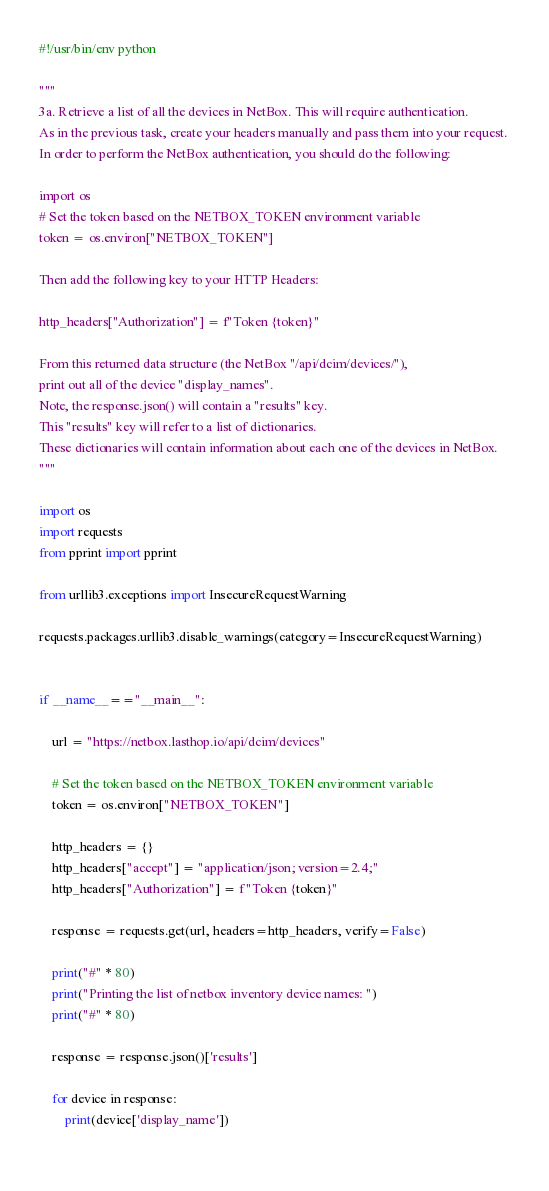<code> <loc_0><loc_0><loc_500><loc_500><_Python_>#!/usr/bin/env python

"""
3a. Retrieve a list of all the devices in NetBox. This will require authentication. 
As in the previous task, create your headers manually and pass them into your request. 
In order to perform the NetBox authentication, you should do the following:

import os
# Set the token based on the NETBOX_TOKEN environment variable
token = os.environ["NETBOX_TOKEN"]

Then add the following key to your HTTP Headers:

http_headers["Authorization"] = f"Token {token}"

From this returned data structure (the NetBox "/api/dcim/devices/"), 
print out all of the device "display_names". 
Note, the response.json() will contain a "results" key. 
This "results" key will refer to a list of dictionaries. 
These dictionaries will contain information about each one of the devices in NetBox.
"""

import os
import requests
from pprint import pprint

from urllib3.exceptions import InsecureRequestWarning

requests.packages.urllib3.disable_warnings(category=InsecureRequestWarning)


if __name__=="__main__":

    url = "https://netbox.lasthop.io/api/dcim/devices"

    # Set the token based on the NETBOX_TOKEN environment variable
    token = os.environ["NETBOX_TOKEN"]

    http_headers = {}
    http_headers["accept"] = "application/json; version=2.4;"
    http_headers["Authorization"] = f"Token {token}"

    response = requests.get(url, headers=http_headers, verify=False)

    print("#" * 80)
    print("Printing the list of netbox inventory device names: ")
    print("#" * 80)

    response = response.json()['results']

    for device in response:
        print(device['display_name'])
    

</code> 